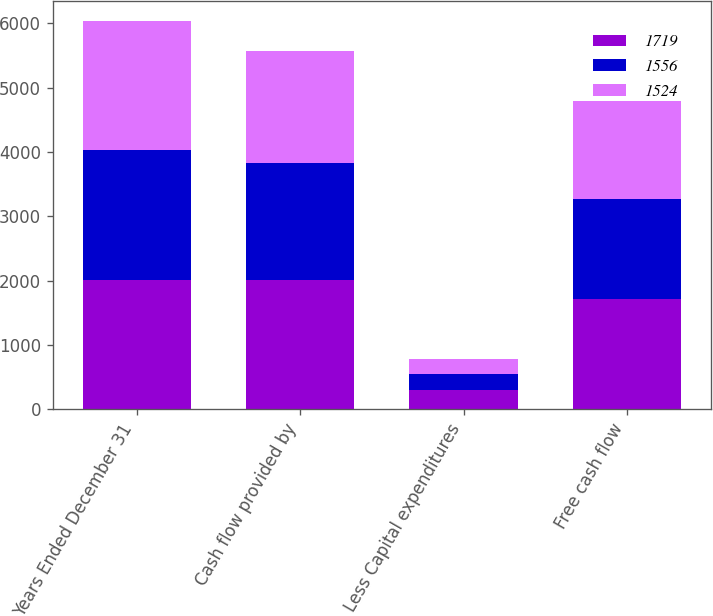Convert chart. <chart><loc_0><loc_0><loc_500><loc_500><stacked_bar_chart><ecel><fcel>Years Ended December 31<fcel>Cash flow provided by<fcel>Less Capital expenditures<fcel>Free cash flow<nl><fcel>1719<fcel>2015<fcel>2009<fcel>290<fcel>1719<nl><fcel>1556<fcel>2014<fcel>1812<fcel>256<fcel>1556<nl><fcel>1524<fcel>2013<fcel>1753<fcel>229<fcel>1524<nl></chart> 